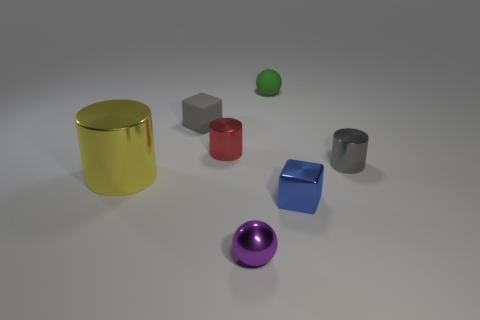How many purple things are tiny rubber blocks or big metal cylinders?
Give a very brief answer. 0. How many other objects are there of the same shape as the blue shiny thing?
Give a very brief answer. 1. Are the small gray cylinder and the tiny blue object made of the same material?
Make the answer very short. Yes. There is a thing that is behind the small red metal object and in front of the green thing; what material is it?
Keep it short and to the point. Rubber. There is a small cube that is on the left side of the purple shiny thing; what is its color?
Your answer should be compact. Gray. Is the number of cylinders that are behind the big metallic object greater than the number of large purple matte objects?
Offer a very short reply. Yes. What number of other objects are there of the same size as the red metal thing?
Provide a short and direct response. 5. How many red objects are right of the blue metallic object?
Give a very brief answer. 0. Are there the same number of big cylinders that are right of the tiny purple metallic object and objects to the left of the tiny metallic cube?
Give a very brief answer. No. There is another rubber object that is the same shape as the purple object; what is its size?
Provide a succinct answer. Small. 